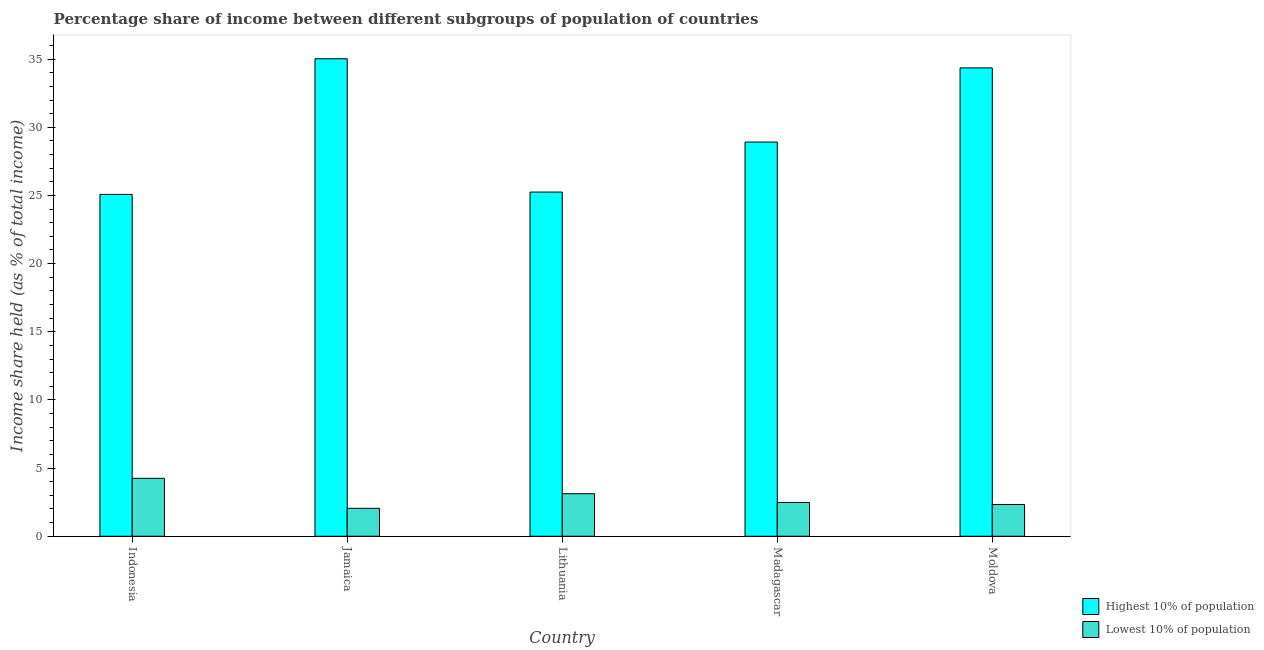How many different coloured bars are there?
Make the answer very short. 2. How many groups of bars are there?
Make the answer very short. 5. Are the number of bars per tick equal to the number of legend labels?
Provide a succinct answer. Yes. What is the label of the 3rd group of bars from the left?
Offer a terse response. Lithuania. In how many cases, is the number of bars for a given country not equal to the number of legend labels?
Keep it short and to the point. 0. What is the income share held by highest 10% of the population in Moldova?
Ensure brevity in your answer.  34.36. Across all countries, what is the maximum income share held by highest 10% of the population?
Your answer should be compact. 35.03. Across all countries, what is the minimum income share held by highest 10% of the population?
Make the answer very short. 25.08. In which country was the income share held by lowest 10% of the population maximum?
Provide a short and direct response. Indonesia. What is the total income share held by highest 10% of the population in the graph?
Offer a terse response. 148.64. What is the difference between the income share held by lowest 10% of the population in Jamaica and that in Moldova?
Your answer should be compact. -0.28. What is the difference between the income share held by lowest 10% of the population in Madagascar and the income share held by highest 10% of the population in Indonesia?
Offer a terse response. -22.6. What is the average income share held by highest 10% of the population per country?
Your response must be concise. 29.73. What is the difference between the income share held by lowest 10% of the population and income share held by highest 10% of the population in Moldova?
Provide a succinct answer. -32.03. In how many countries, is the income share held by lowest 10% of the population greater than 12 %?
Your response must be concise. 0. What is the ratio of the income share held by lowest 10% of the population in Madagascar to that in Moldova?
Your answer should be compact. 1.06. Is the income share held by lowest 10% of the population in Jamaica less than that in Moldova?
Your answer should be very brief. Yes. What is the difference between the highest and the second highest income share held by lowest 10% of the population?
Give a very brief answer. 1.13. What is the difference between the highest and the lowest income share held by lowest 10% of the population?
Give a very brief answer. 2.2. Is the sum of the income share held by highest 10% of the population in Madagascar and Moldova greater than the maximum income share held by lowest 10% of the population across all countries?
Give a very brief answer. Yes. What does the 1st bar from the left in Madagascar represents?
Make the answer very short. Highest 10% of population. What does the 2nd bar from the right in Lithuania represents?
Provide a succinct answer. Highest 10% of population. Are all the bars in the graph horizontal?
Ensure brevity in your answer.  No. What is the difference between two consecutive major ticks on the Y-axis?
Your answer should be very brief. 5. What is the title of the graph?
Make the answer very short. Percentage share of income between different subgroups of population of countries. Does "State government" appear as one of the legend labels in the graph?
Your response must be concise. No. What is the label or title of the X-axis?
Offer a very short reply. Country. What is the label or title of the Y-axis?
Offer a very short reply. Income share held (as % of total income). What is the Income share held (as % of total income) of Highest 10% of population in Indonesia?
Provide a succinct answer. 25.08. What is the Income share held (as % of total income) of Lowest 10% of population in Indonesia?
Keep it short and to the point. 4.25. What is the Income share held (as % of total income) in Highest 10% of population in Jamaica?
Your response must be concise. 35.03. What is the Income share held (as % of total income) of Lowest 10% of population in Jamaica?
Give a very brief answer. 2.05. What is the Income share held (as % of total income) in Highest 10% of population in Lithuania?
Make the answer very short. 25.25. What is the Income share held (as % of total income) of Lowest 10% of population in Lithuania?
Your response must be concise. 3.12. What is the Income share held (as % of total income) in Highest 10% of population in Madagascar?
Make the answer very short. 28.92. What is the Income share held (as % of total income) of Lowest 10% of population in Madagascar?
Offer a terse response. 2.48. What is the Income share held (as % of total income) of Highest 10% of population in Moldova?
Offer a very short reply. 34.36. What is the Income share held (as % of total income) of Lowest 10% of population in Moldova?
Provide a succinct answer. 2.33. Across all countries, what is the maximum Income share held (as % of total income) in Highest 10% of population?
Give a very brief answer. 35.03. Across all countries, what is the maximum Income share held (as % of total income) of Lowest 10% of population?
Offer a very short reply. 4.25. Across all countries, what is the minimum Income share held (as % of total income) of Highest 10% of population?
Keep it short and to the point. 25.08. Across all countries, what is the minimum Income share held (as % of total income) of Lowest 10% of population?
Provide a succinct answer. 2.05. What is the total Income share held (as % of total income) in Highest 10% of population in the graph?
Provide a short and direct response. 148.64. What is the total Income share held (as % of total income) of Lowest 10% of population in the graph?
Your answer should be very brief. 14.23. What is the difference between the Income share held (as % of total income) of Highest 10% of population in Indonesia and that in Jamaica?
Offer a terse response. -9.95. What is the difference between the Income share held (as % of total income) of Lowest 10% of population in Indonesia and that in Jamaica?
Give a very brief answer. 2.2. What is the difference between the Income share held (as % of total income) in Highest 10% of population in Indonesia and that in Lithuania?
Ensure brevity in your answer.  -0.17. What is the difference between the Income share held (as % of total income) in Lowest 10% of population in Indonesia and that in Lithuania?
Your answer should be compact. 1.13. What is the difference between the Income share held (as % of total income) of Highest 10% of population in Indonesia and that in Madagascar?
Make the answer very short. -3.84. What is the difference between the Income share held (as % of total income) of Lowest 10% of population in Indonesia and that in Madagascar?
Keep it short and to the point. 1.77. What is the difference between the Income share held (as % of total income) of Highest 10% of population in Indonesia and that in Moldova?
Provide a short and direct response. -9.28. What is the difference between the Income share held (as % of total income) in Lowest 10% of population in Indonesia and that in Moldova?
Your answer should be very brief. 1.92. What is the difference between the Income share held (as % of total income) in Highest 10% of population in Jamaica and that in Lithuania?
Offer a very short reply. 9.78. What is the difference between the Income share held (as % of total income) of Lowest 10% of population in Jamaica and that in Lithuania?
Ensure brevity in your answer.  -1.07. What is the difference between the Income share held (as % of total income) of Highest 10% of population in Jamaica and that in Madagascar?
Offer a terse response. 6.11. What is the difference between the Income share held (as % of total income) of Lowest 10% of population in Jamaica and that in Madagascar?
Ensure brevity in your answer.  -0.43. What is the difference between the Income share held (as % of total income) in Highest 10% of population in Jamaica and that in Moldova?
Offer a very short reply. 0.67. What is the difference between the Income share held (as % of total income) of Lowest 10% of population in Jamaica and that in Moldova?
Your answer should be very brief. -0.28. What is the difference between the Income share held (as % of total income) in Highest 10% of population in Lithuania and that in Madagascar?
Your response must be concise. -3.67. What is the difference between the Income share held (as % of total income) of Lowest 10% of population in Lithuania and that in Madagascar?
Offer a terse response. 0.64. What is the difference between the Income share held (as % of total income) in Highest 10% of population in Lithuania and that in Moldova?
Provide a short and direct response. -9.11. What is the difference between the Income share held (as % of total income) in Lowest 10% of population in Lithuania and that in Moldova?
Give a very brief answer. 0.79. What is the difference between the Income share held (as % of total income) in Highest 10% of population in Madagascar and that in Moldova?
Offer a terse response. -5.44. What is the difference between the Income share held (as % of total income) of Lowest 10% of population in Madagascar and that in Moldova?
Provide a succinct answer. 0.15. What is the difference between the Income share held (as % of total income) in Highest 10% of population in Indonesia and the Income share held (as % of total income) in Lowest 10% of population in Jamaica?
Provide a short and direct response. 23.03. What is the difference between the Income share held (as % of total income) of Highest 10% of population in Indonesia and the Income share held (as % of total income) of Lowest 10% of population in Lithuania?
Provide a short and direct response. 21.96. What is the difference between the Income share held (as % of total income) of Highest 10% of population in Indonesia and the Income share held (as % of total income) of Lowest 10% of population in Madagascar?
Offer a terse response. 22.6. What is the difference between the Income share held (as % of total income) in Highest 10% of population in Indonesia and the Income share held (as % of total income) in Lowest 10% of population in Moldova?
Ensure brevity in your answer.  22.75. What is the difference between the Income share held (as % of total income) of Highest 10% of population in Jamaica and the Income share held (as % of total income) of Lowest 10% of population in Lithuania?
Offer a terse response. 31.91. What is the difference between the Income share held (as % of total income) of Highest 10% of population in Jamaica and the Income share held (as % of total income) of Lowest 10% of population in Madagascar?
Make the answer very short. 32.55. What is the difference between the Income share held (as % of total income) of Highest 10% of population in Jamaica and the Income share held (as % of total income) of Lowest 10% of population in Moldova?
Provide a short and direct response. 32.7. What is the difference between the Income share held (as % of total income) of Highest 10% of population in Lithuania and the Income share held (as % of total income) of Lowest 10% of population in Madagascar?
Keep it short and to the point. 22.77. What is the difference between the Income share held (as % of total income) of Highest 10% of population in Lithuania and the Income share held (as % of total income) of Lowest 10% of population in Moldova?
Your response must be concise. 22.92. What is the difference between the Income share held (as % of total income) of Highest 10% of population in Madagascar and the Income share held (as % of total income) of Lowest 10% of population in Moldova?
Provide a succinct answer. 26.59. What is the average Income share held (as % of total income) of Highest 10% of population per country?
Ensure brevity in your answer.  29.73. What is the average Income share held (as % of total income) in Lowest 10% of population per country?
Offer a very short reply. 2.85. What is the difference between the Income share held (as % of total income) in Highest 10% of population and Income share held (as % of total income) in Lowest 10% of population in Indonesia?
Give a very brief answer. 20.83. What is the difference between the Income share held (as % of total income) in Highest 10% of population and Income share held (as % of total income) in Lowest 10% of population in Jamaica?
Your response must be concise. 32.98. What is the difference between the Income share held (as % of total income) of Highest 10% of population and Income share held (as % of total income) of Lowest 10% of population in Lithuania?
Offer a terse response. 22.13. What is the difference between the Income share held (as % of total income) of Highest 10% of population and Income share held (as % of total income) of Lowest 10% of population in Madagascar?
Ensure brevity in your answer.  26.44. What is the difference between the Income share held (as % of total income) of Highest 10% of population and Income share held (as % of total income) of Lowest 10% of population in Moldova?
Offer a very short reply. 32.03. What is the ratio of the Income share held (as % of total income) of Highest 10% of population in Indonesia to that in Jamaica?
Provide a short and direct response. 0.72. What is the ratio of the Income share held (as % of total income) of Lowest 10% of population in Indonesia to that in Jamaica?
Provide a short and direct response. 2.07. What is the ratio of the Income share held (as % of total income) of Lowest 10% of population in Indonesia to that in Lithuania?
Make the answer very short. 1.36. What is the ratio of the Income share held (as % of total income) in Highest 10% of population in Indonesia to that in Madagascar?
Keep it short and to the point. 0.87. What is the ratio of the Income share held (as % of total income) of Lowest 10% of population in Indonesia to that in Madagascar?
Provide a succinct answer. 1.71. What is the ratio of the Income share held (as % of total income) of Highest 10% of population in Indonesia to that in Moldova?
Give a very brief answer. 0.73. What is the ratio of the Income share held (as % of total income) of Lowest 10% of population in Indonesia to that in Moldova?
Offer a terse response. 1.82. What is the ratio of the Income share held (as % of total income) of Highest 10% of population in Jamaica to that in Lithuania?
Make the answer very short. 1.39. What is the ratio of the Income share held (as % of total income) of Lowest 10% of population in Jamaica to that in Lithuania?
Provide a succinct answer. 0.66. What is the ratio of the Income share held (as % of total income) of Highest 10% of population in Jamaica to that in Madagascar?
Your response must be concise. 1.21. What is the ratio of the Income share held (as % of total income) in Lowest 10% of population in Jamaica to that in Madagascar?
Provide a short and direct response. 0.83. What is the ratio of the Income share held (as % of total income) of Highest 10% of population in Jamaica to that in Moldova?
Your answer should be very brief. 1.02. What is the ratio of the Income share held (as % of total income) of Lowest 10% of population in Jamaica to that in Moldova?
Provide a succinct answer. 0.88. What is the ratio of the Income share held (as % of total income) in Highest 10% of population in Lithuania to that in Madagascar?
Keep it short and to the point. 0.87. What is the ratio of the Income share held (as % of total income) of Lowest 10% of population in Lithuania to that in Madagascar?
Your answer should be compact. 1.26. What is the ratio of the Income share held (as % of total income) in Highest 10% of population in Lithuania to that in Moldova?
Ensure brevity in your answer.  0.73. What is the ratio of the Income share held (as % of total income) in Lowest 10% of population in Lithuania to that in Moldova?
Keep it short and to the point. 1.34. What is the ratio of the Income share held (as % of total income) in Highest 10% of population in Madagascar to that in Moldova?
Ensure brevity in your answer.  0.84. What is the ratio of the Income share held (as % of total income) in Lowest 10% of population in Madagascar to that in Moldova?
Ensure brevity in your answer.  1.06. What is the difference between the highest and the second highest Income share held (as % of total income) in Highest 10% of population?
Give a very brief answer. 0.67. What is the difference between the highest and the second highest Income share held (as % of total income) in Lowest 10% of population?
Ensure brevity in your answer.  1.13. What is the difference between the highest and the lowest Income share held (as % of total income) in Highest 10% of population?
Provide a short and direct response. 9.95. 